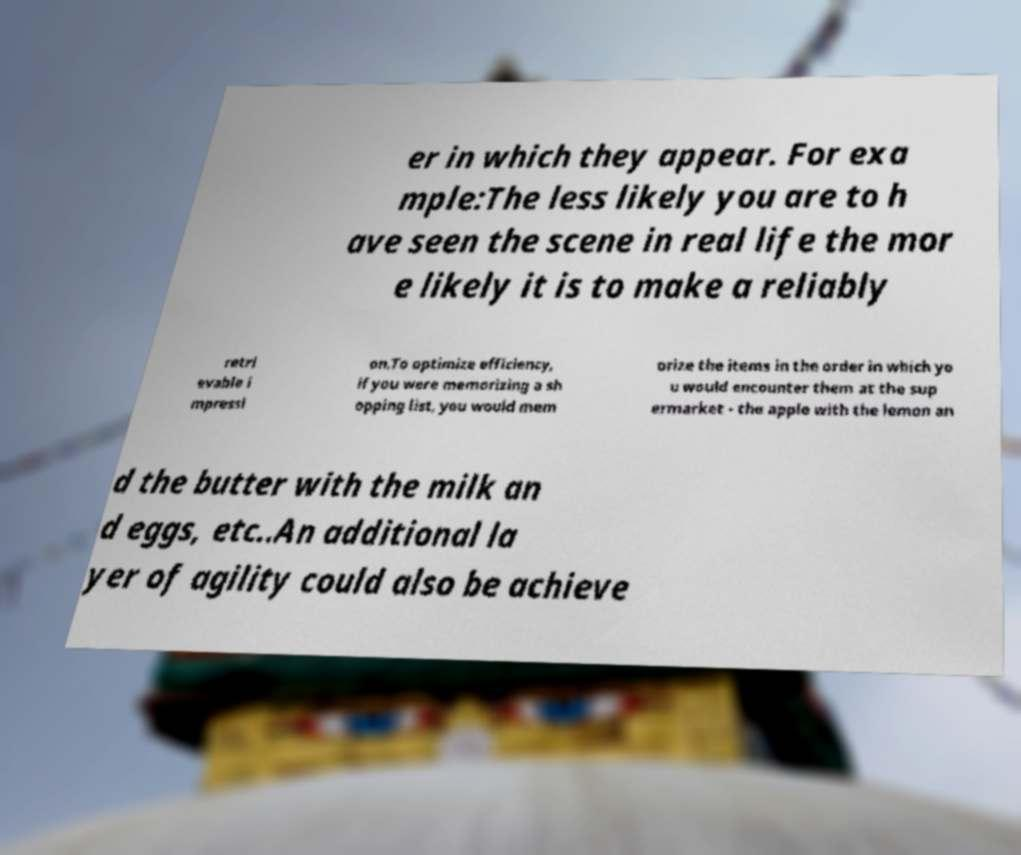Could you assist in decoding the text presented in this image and type it out clearly? er in which they appear. For exa mple:The less likely you are to h ave seen the scene in real life the mor e likely it is to make a reliably retri evable i mpressi on.To optimize efficiency, if you were memorizing a sh opping list, you would mem orize the items in the order in which yo u would encounter them at the sup ermarket - the apple with the lemon an d the butter with the milk an d eggs, etc..An additional la yer of agility could also be achieve 